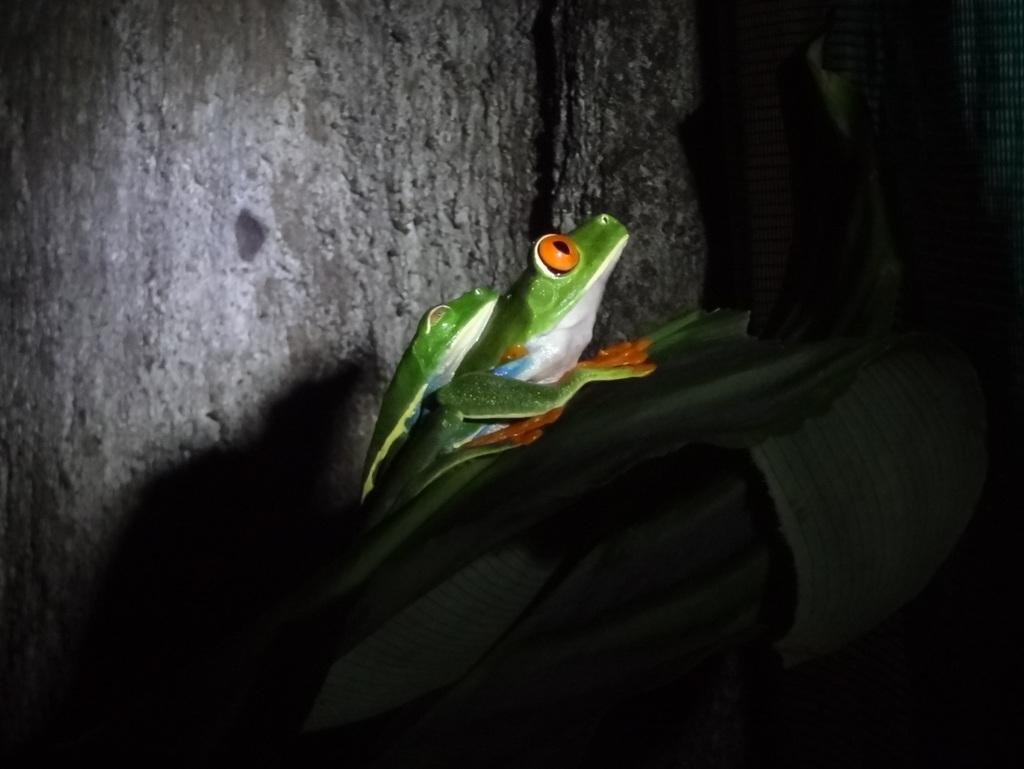What color is predominant in the image? The image contains green color. Can you describe any specific features of the leaves in the image? There are orange color eyes on the leaves in the image. What type of poison is being used on the cactus in the image? There is no cactus or poison present in the image; it features leaves with orange color eyes. What error can be seen in the image? There is no error present in the image; it shows leaves with orange color eyes on a green background. 